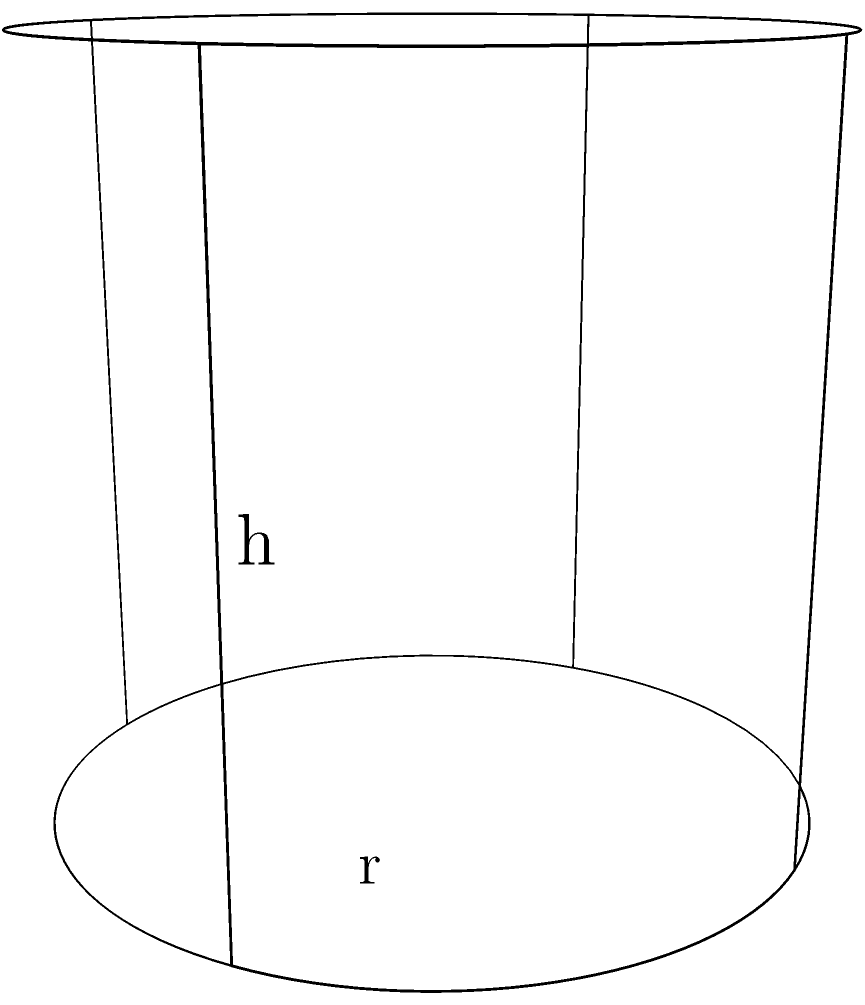As the founder of a small charity organization, you want to optimize the size of cylindrical donation boxes. The material cost for the base and top is $\$0.05$ per square inch, while the cost for the side is $\$0.03$ per square inch. If you want to create a donation box with a volume of $200\pi$ cubic inches, what dimensions (radius and height) will minimize the total cost of materials? Let's approach this step-by-step:

1) Let $r$ be the radius and $h$ be the height of the cylinder.

2) The volume of a cylinder is $V = \pi r^2 h$. We're given that $V = 200\pi$, so:
   $200\pi = \pi r^2 h$
   $200 = r^2 h$

3) The surface area of a cylinder consists of two circular ends and the side:
   $A_{total} = 2\pi r^2 + 2\pi rh$

4) The cost function will be:
   $C = 0.05(2\pi r^2) + 0.03(2\pi rh)$
   $C = 0.1\pi r^2 + 0.06\pi rh$

5) We can substitute $h = \frac{200}{r^2}$ from step 2:
   $C = 0.1\pi r^2 + 0.06\pi r(\frac{200}{r^2})$
   $C = 0.1\pi r^2 + \frac{12\pi}{r}$

6) To find the minimum cost, we differentiate $C$ with respect to $r$ and set it to zero:
   $\frac{dC}{dr} = 0.2\pi r - \frac{12\pi}{r^2} = 0$

7) Solving this equation:
   $0.2\pi r^3 = 12\pi$
   $r^3 = 60$
   $r = \sqrt[3]{60} \approx 3.915$ inches

8) We can find $h$ using the equation from step 2:
   $h = \frac{200}{r^2} \approx 13.052$ inches

9) To verify this is a minimum, we can check the second derivative is positive at this point.
Answer: $r \approx 3.915$ inches, $h \approx 13.052$ inches 